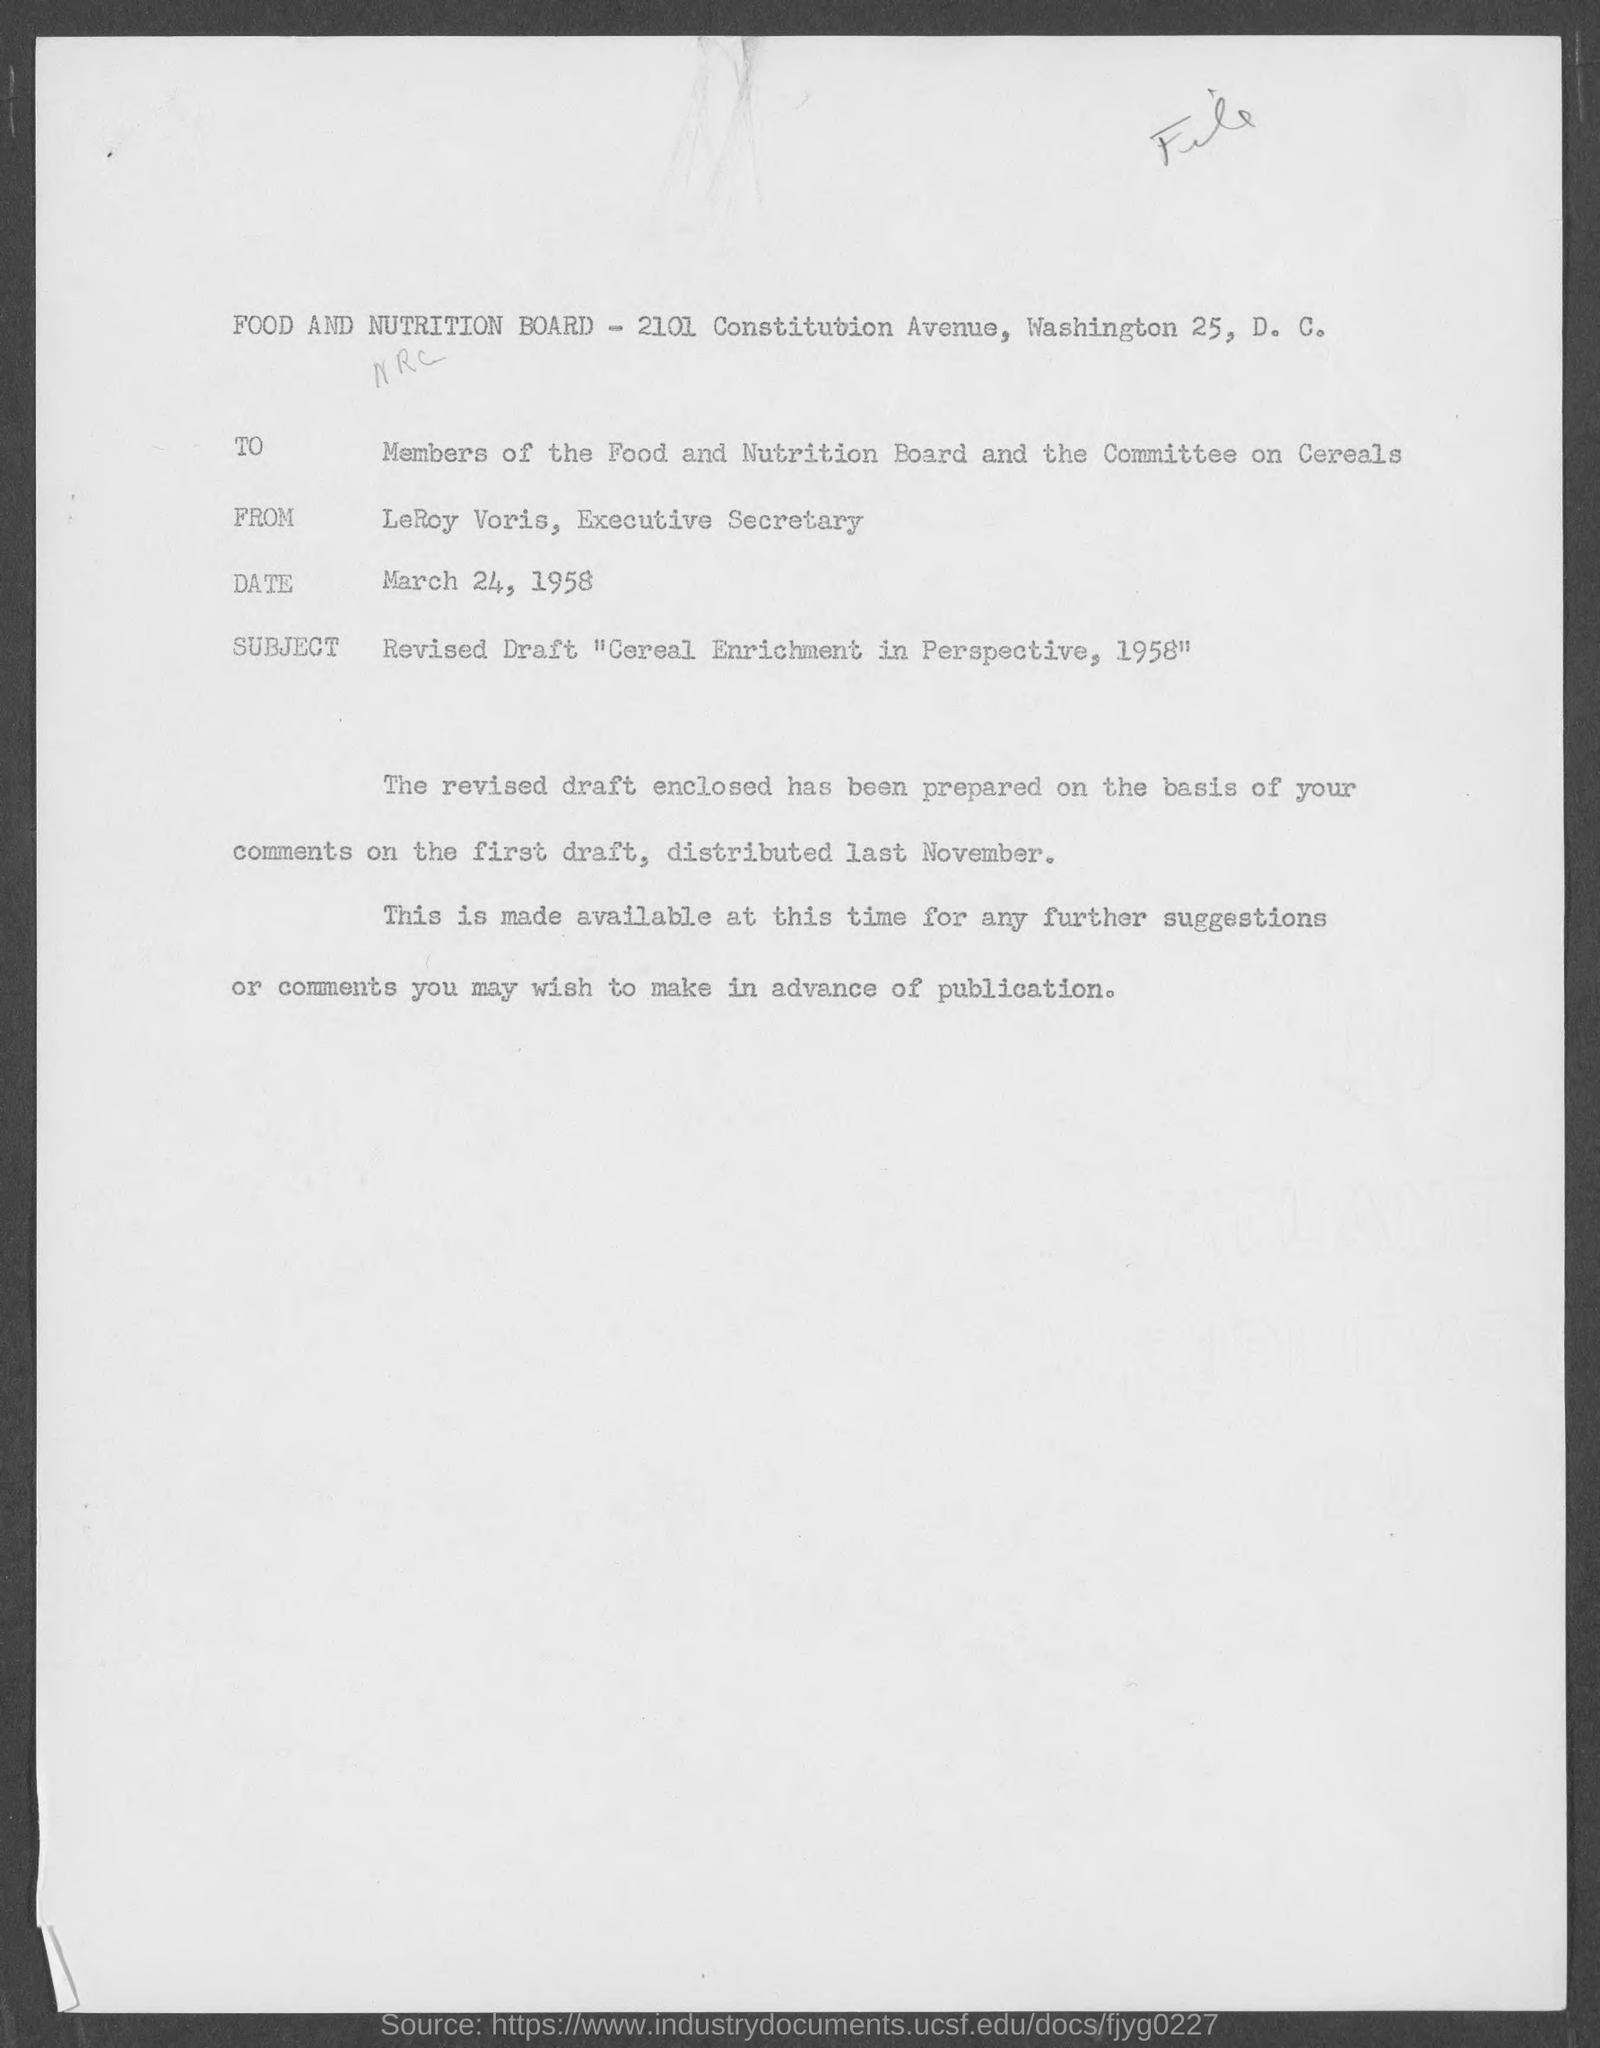When is the memorandum dated?
Your answer should be very brief. March 24, 1958. What is the position of leroy voris?
Provide a short and direct response. Executive Secretary. What is the subject of the memorandum?
Make the answer very short. Revised Draft " Cereal Enrichment in Perspective, 1958". 